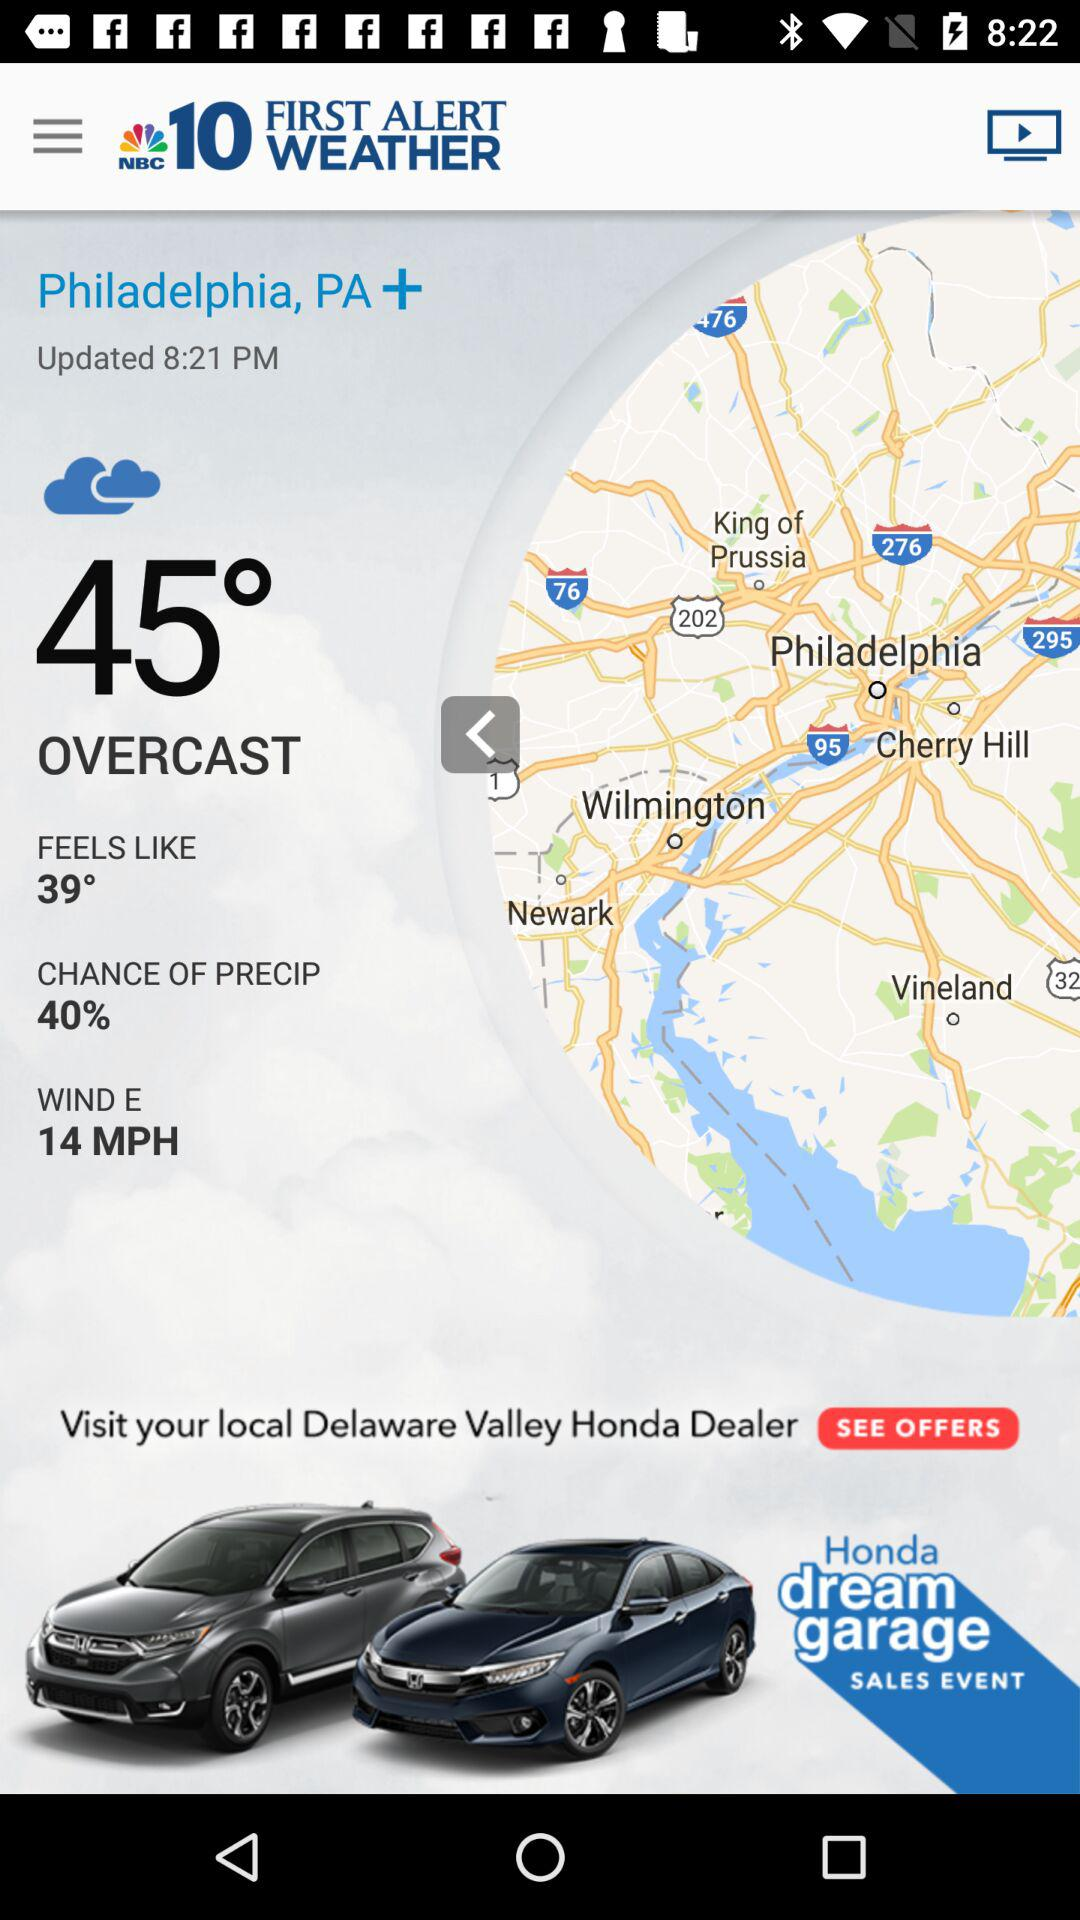How many degrees warmer is the current temperature than the feels-like temperature?
Answer the question using a single word or phrase. 6 